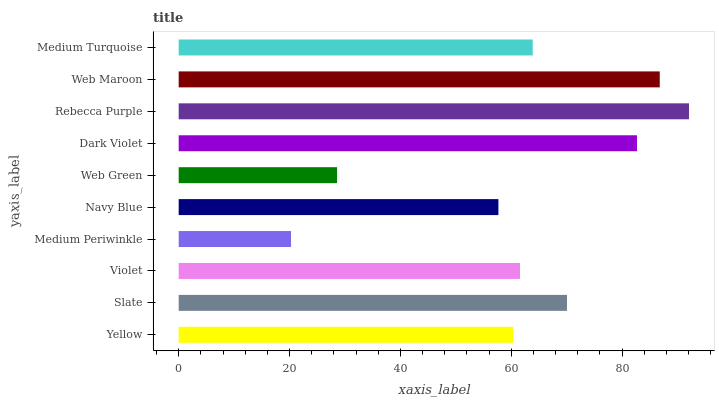Is Medium Periwinkle the minimum?
Answer yes or no. Yes. Is Rebecca Purple the maximum?
Answer yes or no. Yes. Is Slate the minimum?
Answer yes or no. No. Is Slate the maximum?
Answer yes or no. No. Is Slate greater than Yellow?
Answer yes or no. Yes. Is Yellow less than Slate?
Answer yes or no. Yes. Is Yellow greater than Slate?
Answer yes or no. No. Is Slate less than Yellow?
Answer yes or no. No. Is Medium Turquoise the high median?
Answer yes or no. Yes. Is Violet the low median?
Answer yes or no. Yes. Is Yellow the high median?
Answer yes or no. No. Is Navy Blue the low median?
Answer yes or no. No. 